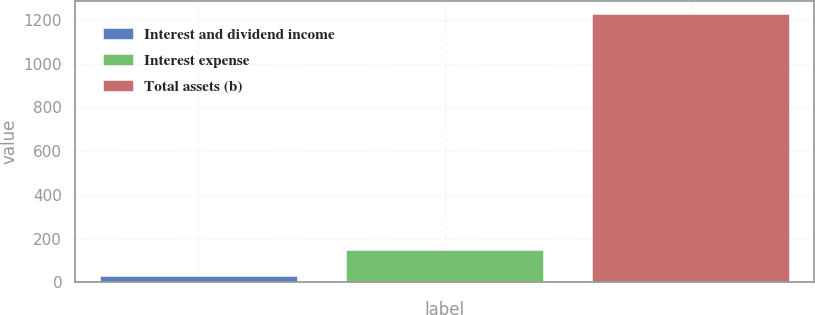<chart> <loc_0><loc_0><loc_500><loc_500><bar_chart><fcel>Interest and dividend income<fcel>Interest expense<fcel>Total assets (b)<nl><fcel>30<fcel>149.7<fcel>1227<nl></chart> 